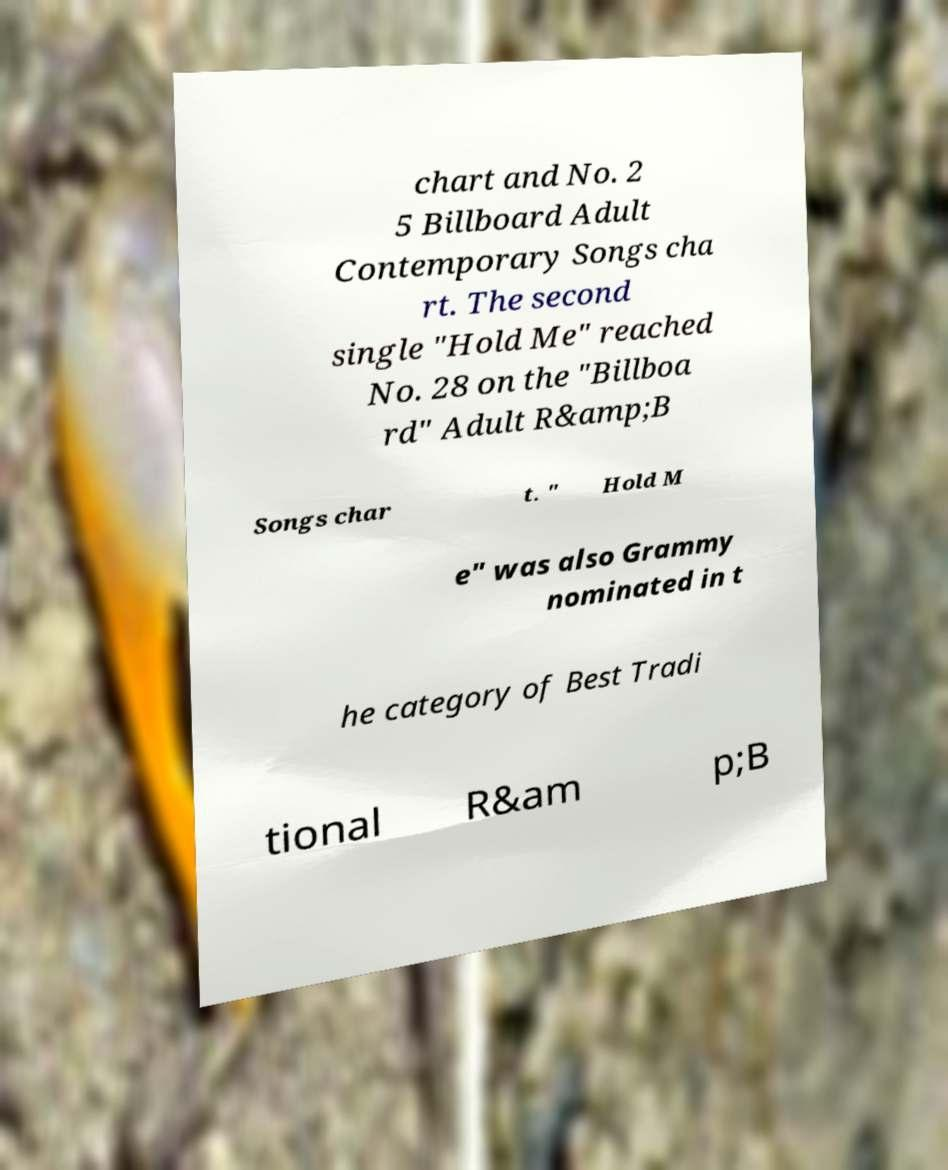Can you read and provide the text displayed in the image?This photo seems to have some interesting text. Can you extract and type it out for me? chart and No. 2 5 Billboard Adult Contemporary Songs cha rt. The second single "Hold Me" reached No. 28 on the "Billboa rd" Adult R&amp;B Songs char t. " Hold M e" was also Grammy nominated in t he category of Best Tradi tional R&am p;B 